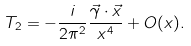<formula> <loc_0><loc_0><loc_500><loc_500>T _ { 2 } = - \frac { i } { 2 \pi ^ { 2 } } \frac { \vec { \gamma } \cdot \vec { x } } { x ^ { 4 } } + O ( x ) .</formula> 